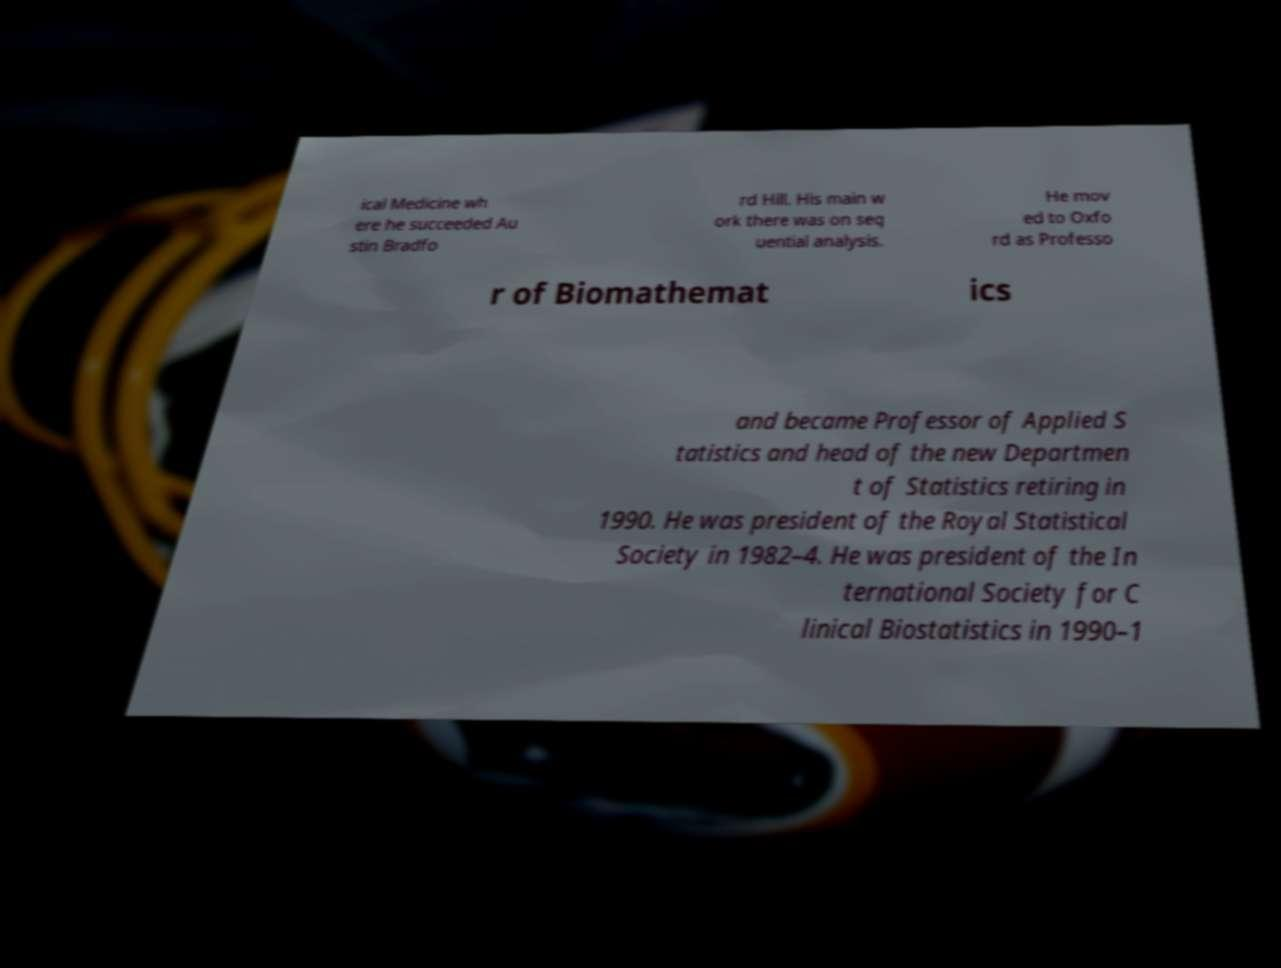Can you read and provide the text displayed in the image?This photo seems to have some interesting text. Can you extract and type it out for me? ical Medicine wh ere he succeeded Au stin Bradfo rd Hill. His main w ork there was on seq uential analysis. He mov ed to Oxfo rd as Professo r of Biomathemat ics and became Professor of Applied S tatistics and head of the new Departmen t of Statistics retiring in 1990. He was president of the Royal Statistical Society in 1982–4. He was president of the In ternational Society for C linical Biostatistics in 1990–1 